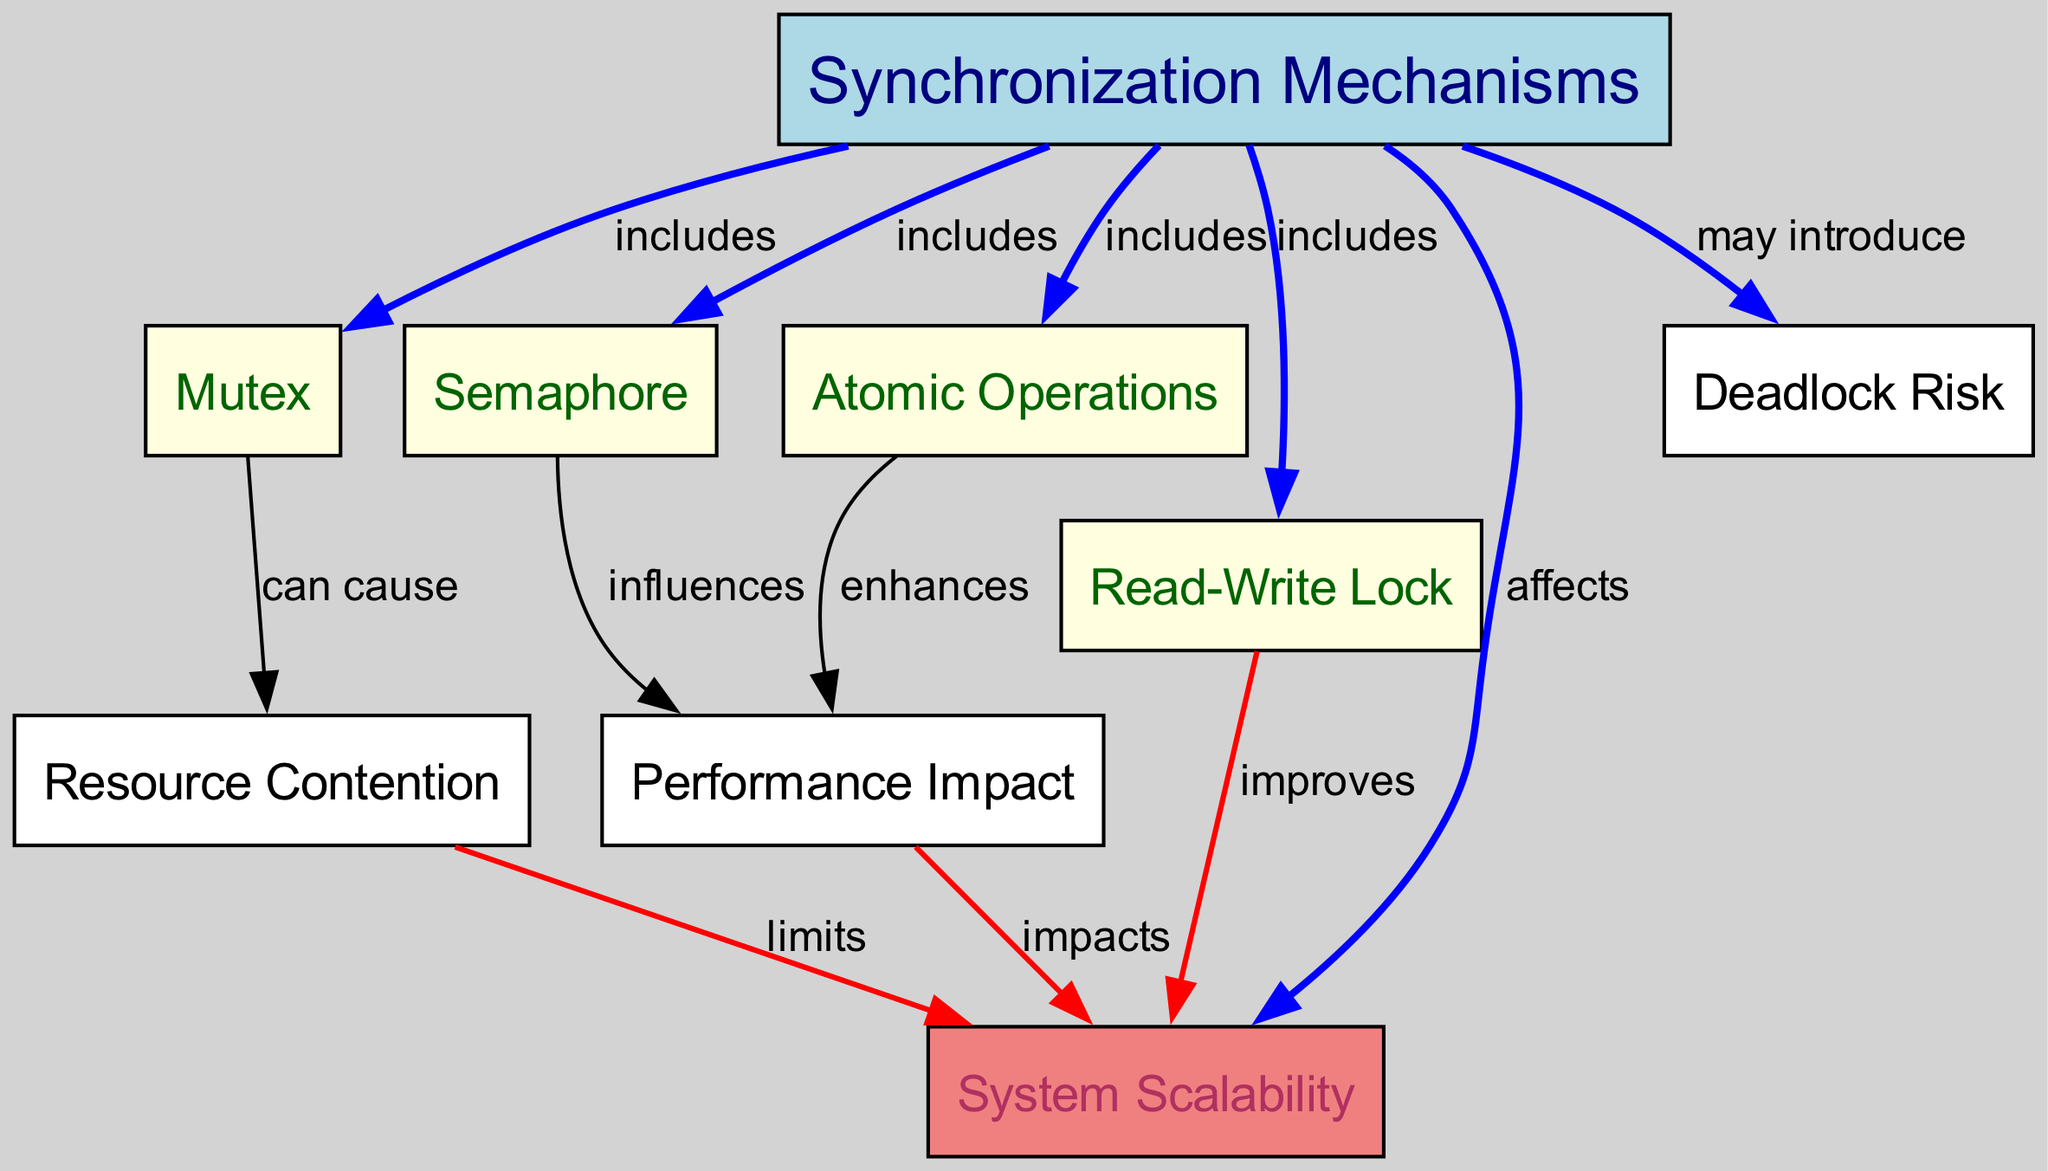What are the four types of synchronization mechanisms depicted in the diagram? The diagram lists four synchronization mechanisms: Mutex, Semaphore, Read-Write Lock, and Atomic Operations. These are all represented as nodes connected to the Synchronization Mechanisms node.
Answer: Mutex, Semaphore, Read-Write Lock, Atomic Operations How many nodes are present in the diagram? The diagram consists of eight nodes in total, including the four synchronization mechanisms, Scalability, Resource Contention, Performance Impact, and Deadlock Risk.
Answer: Eight Which synchronization mechanism can cause resource contention? The diagram indicates that the Mutex can cause Resource Contention, as there is a direct edge from Mutex node to Resource Contention with the label "can cause."
Answer: Mutex How does a semaphore influence system performance? According to the diagram, the edge from the Semaphore to the Performance Impact node indicates that a Semaphore influences performance, as labeled "influences."
Answer: Influences What effect do atomic operations have on performance? The diagram shows an edge from the Atomic Operations node to the Performance Impact node with the label "enhances," indicating that Atomic Operations positively enhance performance.
Answer: Enhances What relationship exists between scalability and contention? The diagram establishes a limiting relationship, stating that Resource Contention limits Scalability. This is shown through an edge from Resource Contention to Scalability labeled "limits."
Answer: Limits How does a read-write lock impact scalability? The Read-Write Lock node in the diagram has an edge pointing towards the Scalability node, demonstrating that it improves scalability based on the label "improves."
Answer: Improves What is the consequence of synchronization mechanisms on deadlock risk? The diagram notes that synchronization mechanisms may introduce a risk of Deadlock, as shown by the edge connecting Synchronization Mechanisms to Deadlock Risk labeled "may introduce."
Answer: May introduce 